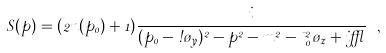<formula> <loc_0><loc_0><loc_500><loc_500>S ( p ) = ( 2 n ( p _ { 0 } ) + 1 ) \frac { i } { ( p _ { 0 } - \omega \tau _ { y } ) ^ { 2 } - { p } ^ { 2 } - m ^ { 2 } - \mu _ { 0 } ^ { 2 } \tau _ { z } + i \epsilon } \ ,</formula> 